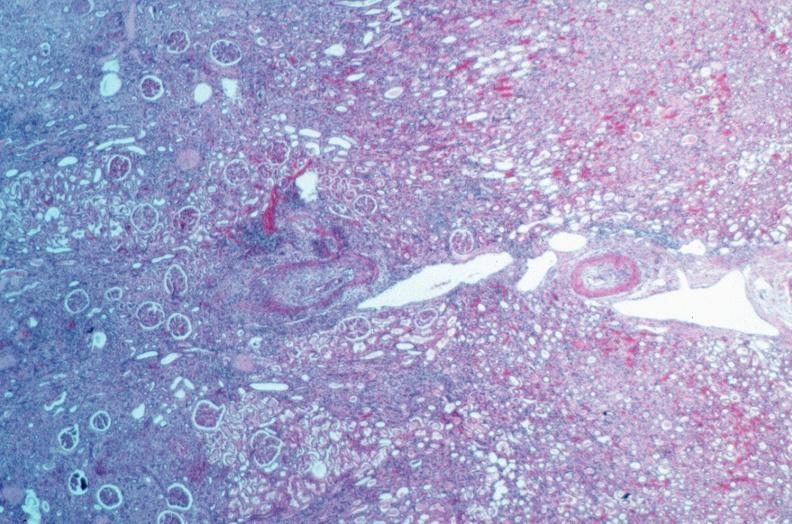what does this image show?
Answer the question using a single word or phrase. Vasculitis 